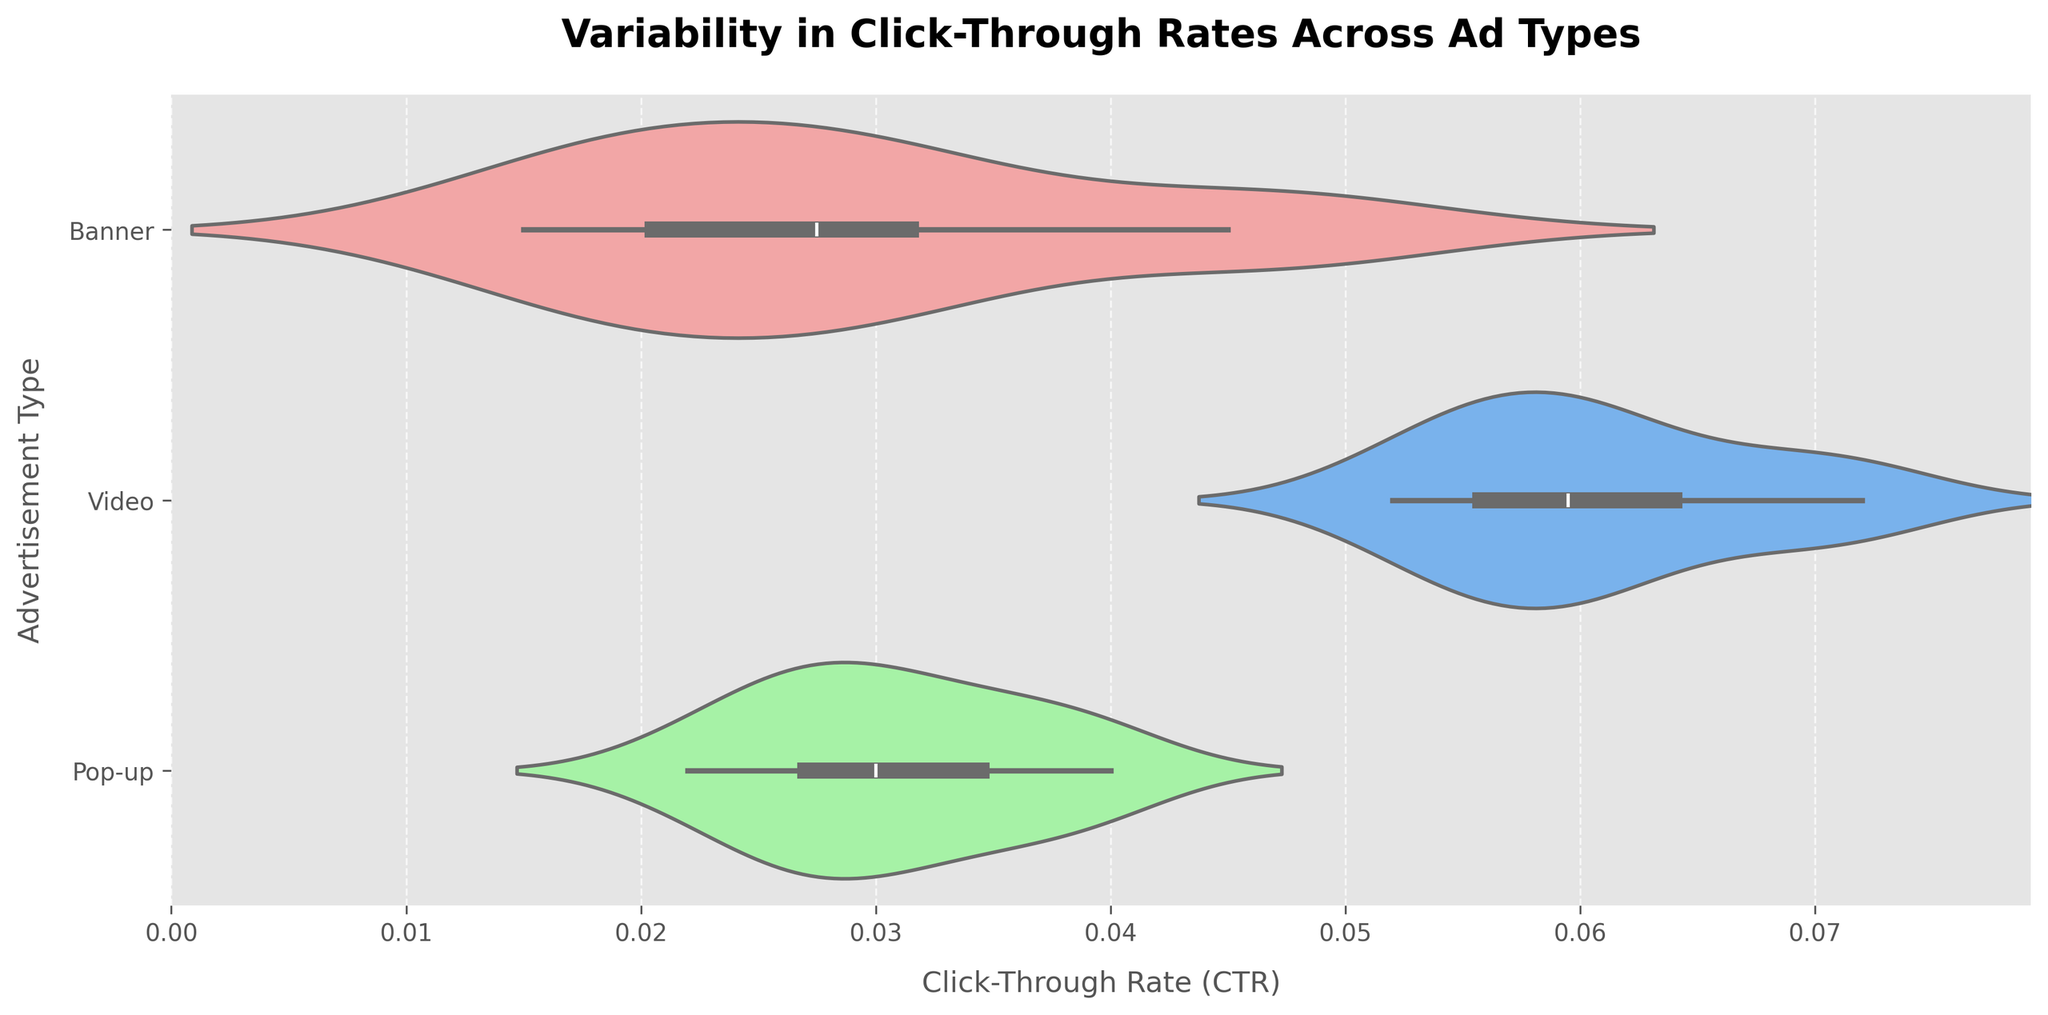What is the title of the chart? The title of the chart is at the top of the figure. It reads "Variability in Click-Through Rates Across Ad Types."
Answer: Variability in Click-Through Rates Across Ad Types Which advertisement type has the highest range of click-through rates? To find the ad type with the highest range, you look at the width of the violin plot distributions on the x-axis. Video ads show the widest range.
Answer: Video What is the approximate maximum click-through rate observed for banner ads? By observing the maximum point on the x-axis for the Banner section of the plot, the maximum CTR for banner ads is around 0.049.
Answer: 0.049 Among the ad types, which one has the lowest median click-through rate? The inner 'box' representation within violin plots gives the median. The Banner ad type has the lowest median CTR.
Answer: Banner Which advertisement type appears to have the most consistent click-through rates? Consistency can be deduced by looking at the narrowness of the distribution. Pop-up ads show the narrowest distribution among the three types, indicating more consistent CTRs.
Answer: Pop-up What is the interquartile range for video ads? The interquartile range is represented by the box within the violin plot. For video ads, the box plot extends approximately from 0.055 to 0.065. So the IQR is 0.065 - 0.055 = 0.01.
Answer: 0.01 Which ad type has the least variability in click-through rates? The width of the violin plot indicates variability. Pop-up ads have the least variability compared to banner and video ads, as seen by the narrow distribution.
Answer: Pop-up How do the medians of the three ad types compare? By looking at the central lines in the boxes of each plot, you can infer the medians. Video ads have the highest median, followed by Pop-up ads, and then Banner ads.
Answer: Video > Pop-up > Banner What is the range of click-through rates for pop-up ads? The range is the difference between the maximum and minimum values. For pop-up ads, it's from approximately 0.022 to 0.040, so the range is 0.040 - 0.022 = 0.018.
Answer: 0.018 Comparing the mean click-through rate of Banner and Video ads, which one is higher? Evaluate the overall spread and central tendency. The mean of video ads is higher as its distribution is centered around higher CTR values compared to Banner ads.
Answer: Video 